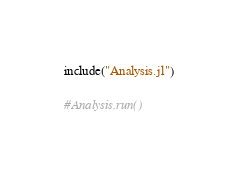<code> <loc_0><loc_0><loc_500><loc_500><_Julia_>include("Analysis.jl")

#Analysis.run()
</code> 